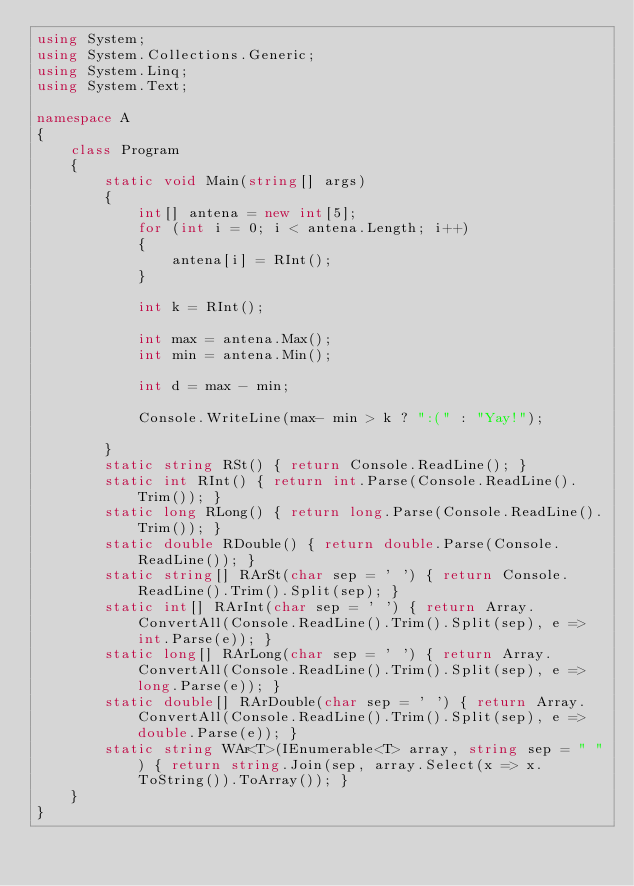<code> <loc_0><loc_0><loc_500><loc_500><_C#_>using System;
using System.Collections.Generic;
using System.Linq;
using System.Text;

namespace A
{
    class Program
    {
        static void Main(string[] args)
        {
            int[] antena = new int[5];
            for (int i = 0; i < antena.Length; i++)
            {
                antena[i] = RInt();
            }

            int k = RInt();

            int max = antena.Max();
            int min = antena.Min();

            int d = max - min;
            
            Console.WriteLine(max- min > k ? ":(" : "Yay!");

        }
        static string RSt() { return Console.ReadLine(); }
        static int RInt() { return int.Parse(Console.ReadLine().Trim()); }
        static long RLong() { return long.Parse(Console.ReadLine().Trim()); }
        static double RDouble() { return double.Parse(Console.ReadLine()); }
        static string[] RArSt(char sep = ' ') { return Console.ReadLine().Trim().Split(sep); }
        static int[] RArInt(char sep = ' ') { return Array.ConvertAll(Console.ReadLine().Trim().Split(sep), e => int.Parse(e)); }
        static long[] RArLong(char sep = ' ') { return Array.ConvertAll(Console.ReadLine().Trim().Split(sep), e => long.Parse(e)); }
        static double[] RArDouble(char sep = ' ') { return Array.ConvertAll(Console.ReadLine().Trim().Split(sep), e => double.Parse(e)); }
        static string WAr<T>(IEnumerable<T> array, string sep = " ") { return string.Join(sep, array.Select(x => x.ToString()).ToArray()); }
    }
}
</code> 